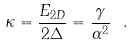<formula> <loc_0><loc_0><loc_500><loc_500>\kappa = \frac { E _ { 2 D } } { 2 \Delta } = \frac { \gamma } { \alpha ^ { 2 } } \ .</formula> 